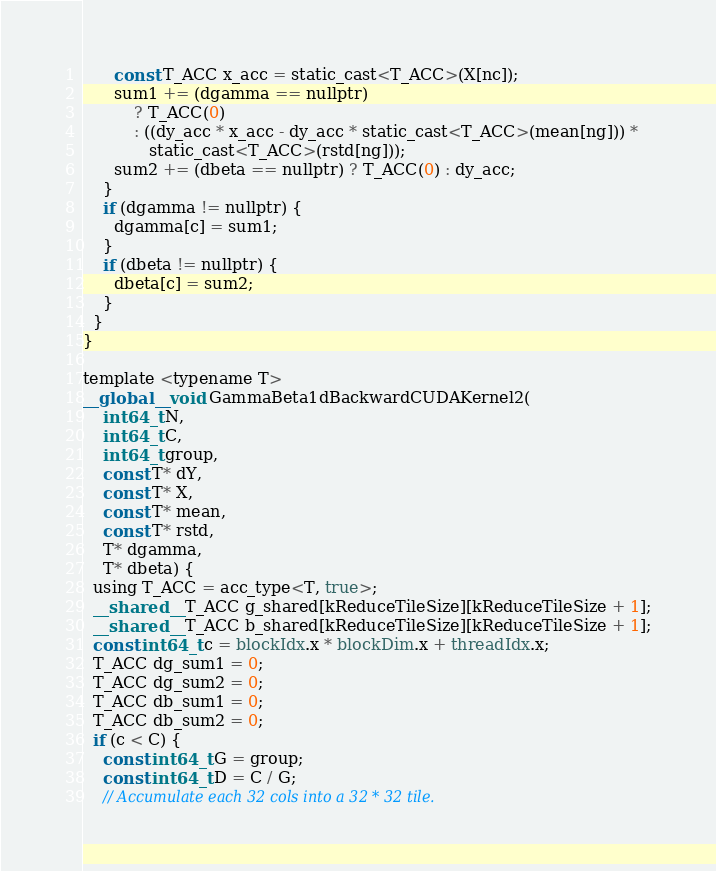Convert code to text. <code><loc_0><loc_0><loc_500><loc_500><_Cuda_>      const T_ACC x_acc = static_cast<T_ACC>(X[nc]);
      sum1 += (dgamma == nullptr)
          ? T_ACC(0)
          : ((dy_acc * x_acc - dy_acc * static_cast<T_ACC>(mean[ng])) *
             static_cast<T_ACC>(rstd[ng]));
      sum2 += (dbeta == nullptr) ? T_ACC(0) : dy_acc;
    }
    if (dgamma != nullptr) {
      dgamma[c] = sum1;
    }
    if (dbeta != nullptr) {
      dbeta[c] = sum2;
    }
  }
}

template <typename T>
__global__ void GammaBeta1dBackwardCUDAKernel2(
    int64_t N,
    int64_t C,
    int64_t group,
    const T* dY,
    const T* X,
    const T* mean,
    const T* rstd,
    T* dgamma,
    T* dbeta) {
  using T_ACC = acc_type<T, true>;
  __shared__ T_ACC g_shared[kReduceTileSize][kReduceTileSize + 1];
  __shared__ T_ACC b_shared[kReduceTileSize][kReduceTileSize + 1];
  const int64_t c = blockIdx.x * blockDim.x + threadIdx.x;
  T_ACC dg_sum1 = 0;
  T_ACC dg_sum2 = 0;
  T_ACC db_sum1 = 0;
  T_ACC db_sum2 = 0;
  if (c < C) {
    const int64_t G = group;
    const int64_t D = C / G;
    // Accumulate each 32 cols into a 32 * 32 tile.</code> 